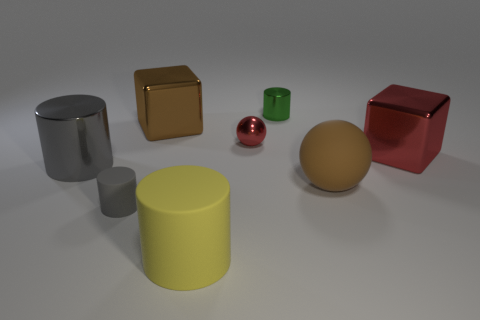The thing that is the same color as the tiny matte cylinder is what size?
Provide a short and direct response. Large. How many blue things are either big rubber balls or big metal cylinders?
Make the answer very short. 0. How many red shiny objects have the same shape as the big yellow object?
Your response must be concise. 0. What shape is the green shiny object that is the same size as the gray matte object?
Offer a terse response. Cylinder. There is a brown metal thing; are there any small rubber cylinders right of it?
Your answer should be very brief. No. Is there a metal ball that is behind the big thing to the left of the small gray matte cylinder?
Provide a succinct answer. Yes. Are there fewer big gray shiny cylinders on the right side of the large brown block than brown rubber balls on the right side of the large red cube?
Offer a very short reply. No. Is there any other thing that has the same size as the brown metallic thing?
Keep it short and to the point. Yes. What shape is the big red shiny object?
Your answer should be very brief. Cube. What material is the large brown thing in front of the gray shiny object?
Your response must be concise. Rubber. 